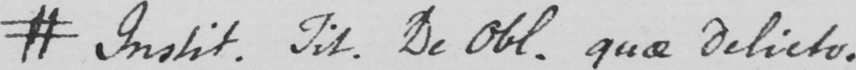Can you tell me what this handwritten text says? # Instit . Tit . De Obl . quae delicto . 